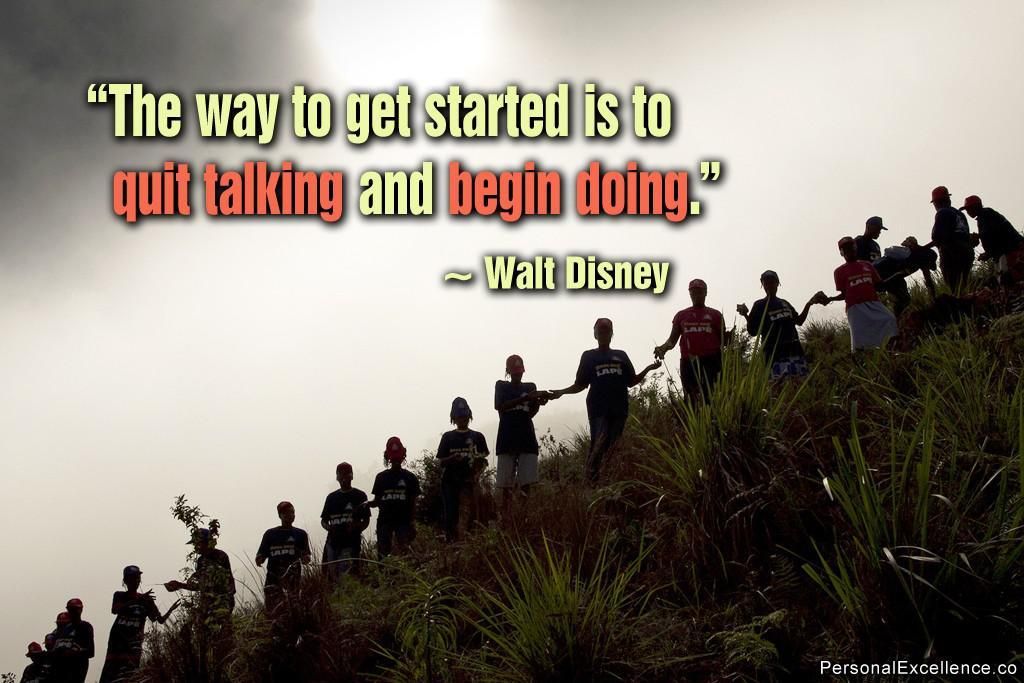<image>
Create a compact narrative representing the image presented. The picture of random people on a hill features a quote from Walt Disney. 